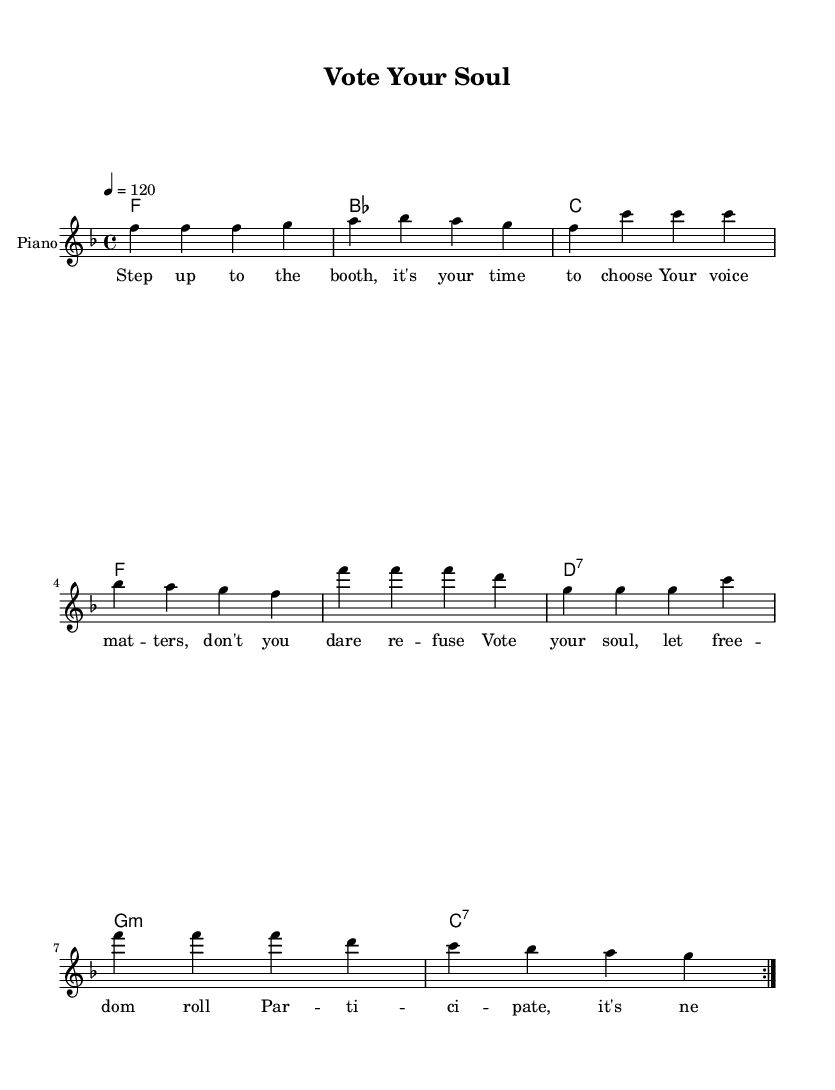What is the key signature of this music? The key signature is F major, which has one flat (B flat).
Answer: F major What is the time signature of this music? The time signature is 4/4, indicating four beats per measure.
Answer: 4/4 What is the tempo marking of the piece? The tempo marking indicates a speed of 120 beats per minute.
Answer: 120 How many measures are in the melody before it repeats? The melody has eight measures before it repeats, indicated by the volta markings.
Answer: 8 What is the dominant chord used in the harmony section? The dominant chord here is C major, which typically resolves to the tonic F major.
Answer: C How does the lyric "Vote your soul" contribute to the theme of participation? The phrase "Vote your soul" emphasizes the importance of individual expression in the democratic process, encouraging active engagement in elections.
Answer: Individual expression 